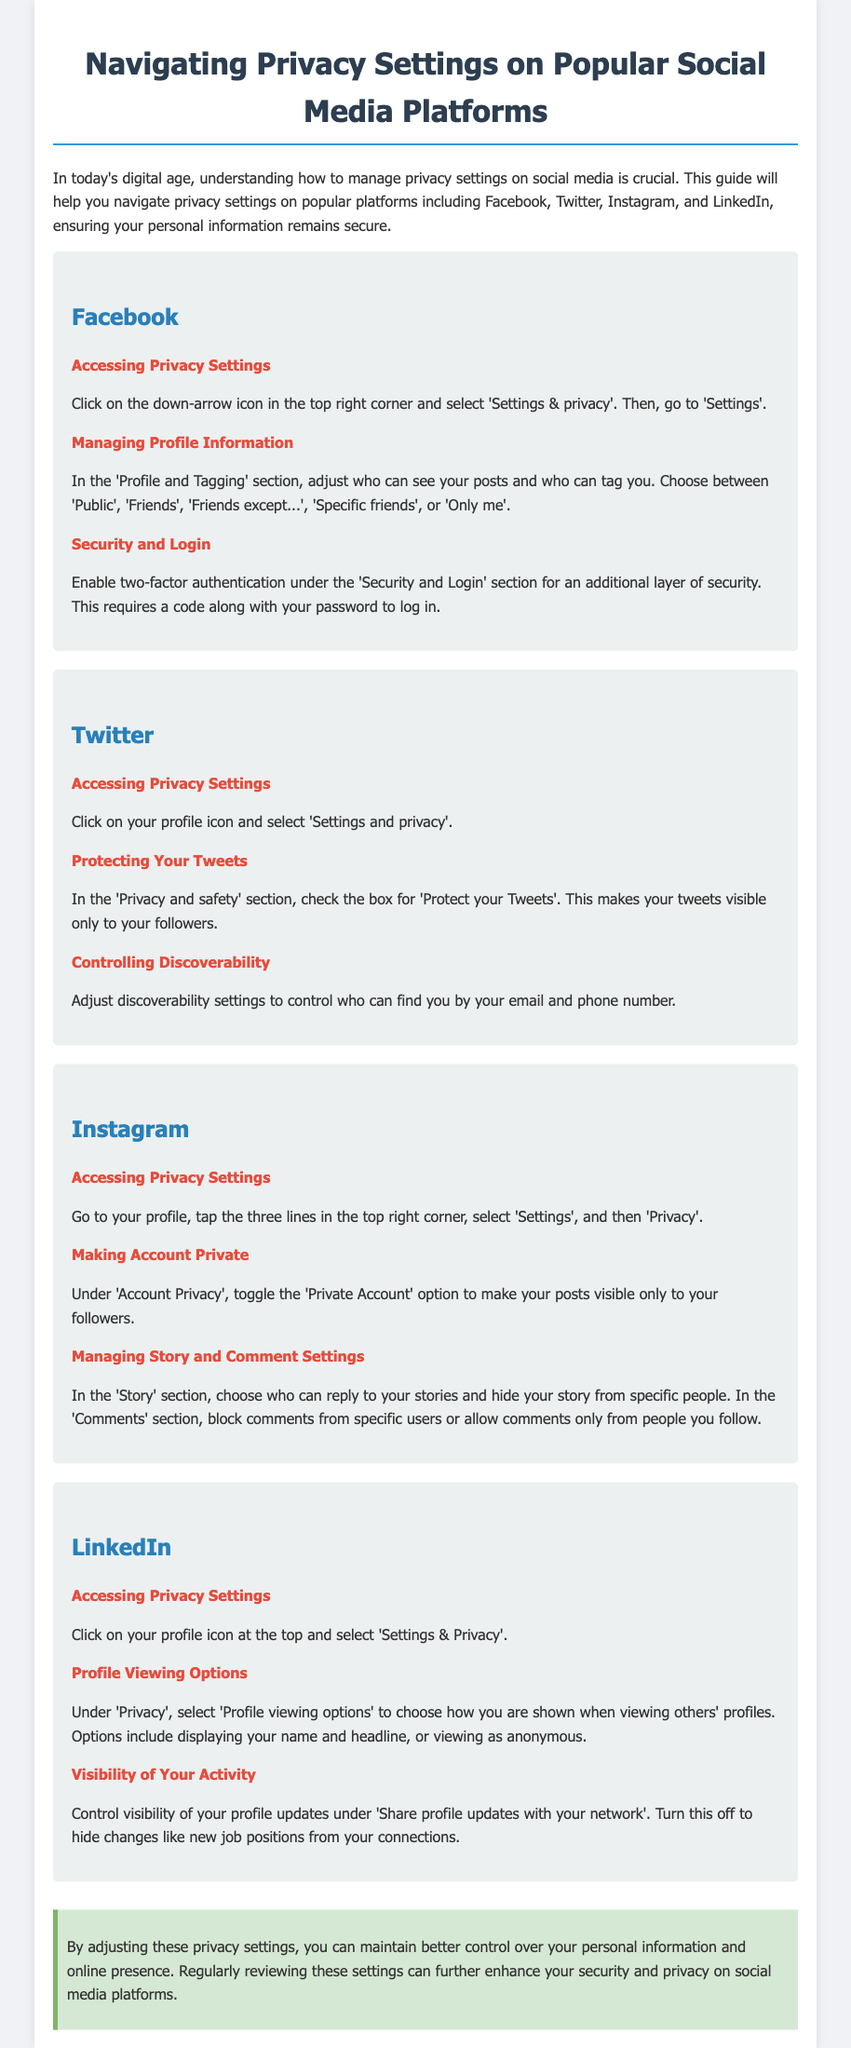What is the first step to access Facebook privacy settings? The document states to click on the down-arrow icon in the top right corner and select 'Settings & privacy'.
Answer: Click on the down-arrow icon What section allows you to manage profile information on Facebook? In the document, 'Profile and Tagging' is mentioned as the section to manage profile information.
Answer: Profile and Tagging How can you protect your tweets on Twitter? The document indicates checking the box for 'Protect your Tweets' under the 'Privacy and safety' section.
Answer: Protect your Tweets What option must be toggled to make an Instagram account private? The document specifies to toggle the 'Private Account' option under 'Account Privacy'.
Answer: Private Account In LinkedIn, what can you do under 'Profile viewing options'? The document explains that you can choose how you are shown when viewing others' profiles.
Answer: Choose how you are shown What is the purpose of enabling two-factor authentication on Facebook? According to the document, it provides an additional layer of security requiring a code along with the password to log in.
Answer: Additional layer of security How does Instagram allow you to control your story interactions? The document mentions options to choose who can reply to your stories and to hide your story from specific people.
Answer: Choose who can reply What can you do to make your LinkedIn profile updates less visible? The document states you can turn off 'Share profile updates with your network' to hide job changes.
Answer: Turn off Share profile updates What general advice does the conclusion provide for managing privacy settings? The conclusion suggests regularly reviewing these settings to enhance security and privacy.
Answer: Regularly reviewing settings 